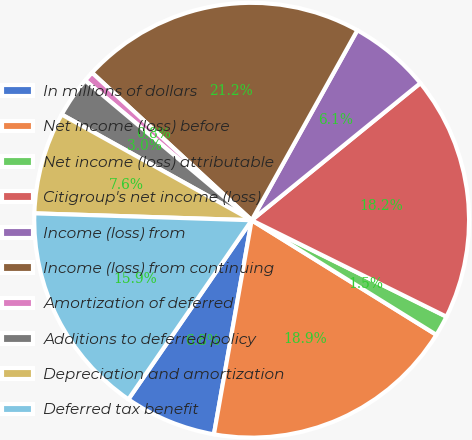<chart> <loc_0><loc_0><loc_500><loc_500><pie_chart><fcel>In millions of dollars<fcel>Net income (loss) before<fcel>Net income (loss) attributable<fcel>Citigroup's net income (loss)<fcel>Income (loss) from<fcel>Income (loss) from continuing<fcel>Amortization of deferred<fcel>Additions to deferred policy<fcel>Depreciation and amortization<fcel>Deferred tax benefit<nl><fcel>6.82%<fcel>18.94%<fcel>1.52%<fcel>18.18%<fcel>6.06%<fcel>21.21%<fcel>0.76%<fcel>3.03%<fcel>7.58%<fcel>15.91%<nl></chart> 